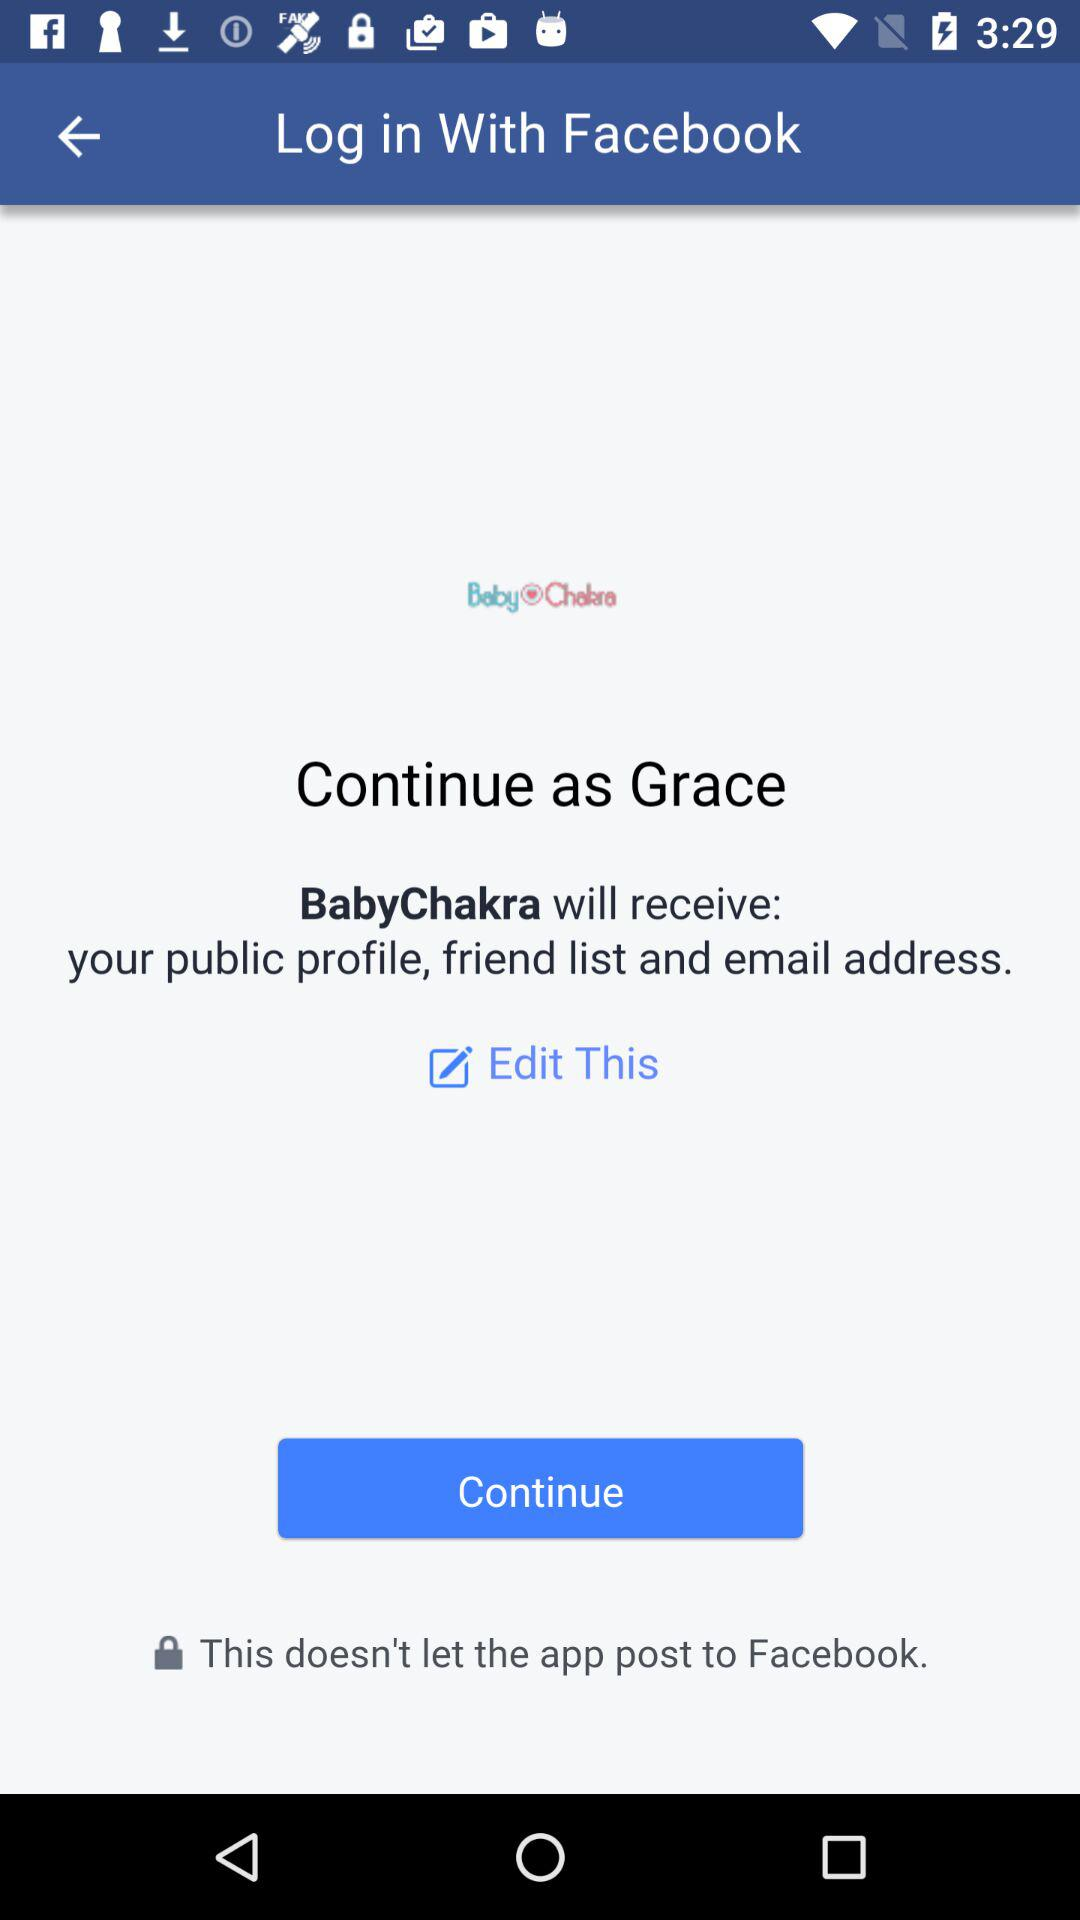Who will receive the public figure, friend list and email address? The application that will receive the public profile, friend list and email address is "BabyChakra". 